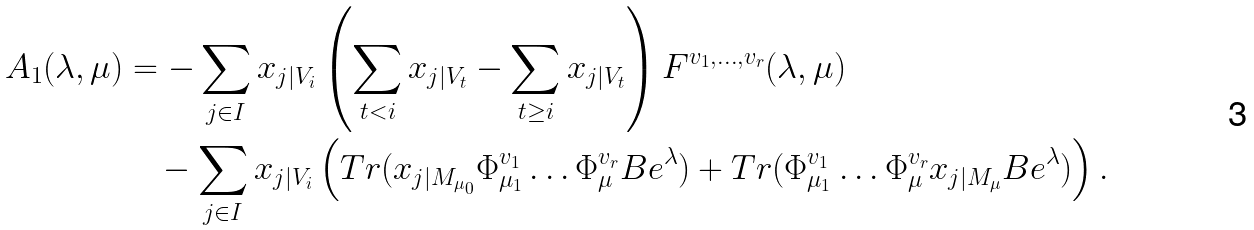Convert formula to latex. <formula><loc_0><loc_0><loc_500><loc_500>A _ { 1 } ( \lambda , \mu ) & = - \sum _ { j \in I } x _ { j | V _ { i } } \left ( \sum _ { t < i } x _ { j | V _ { t } } - \sum _ { t \geq i } x _ { j | V _ { t } } \right ) F ^ { v _ { 1 } , \dots , v _ { r } } ( \lambda , \mu ) \\ & \quad - \sum _ { j \in I } x _ { j | V _ { i } } \left ( T r ( x _ { j | M _ { \mu _ { 0 } } } \Phi ^ { v _ { 1 } } _ { \mu _ { 1 } } \dots \Phi ^ { v _ { r } } _ { \mu } B e ^ { \lambda } ) + T r ( \Phi ^ { v _ { 1 } } _ { \mu _ { 1 } } \dots \Phi ^ { v _ { r } } _ { \mu } x _ { j | M _ { \mu } } B e ^ { \lambda } ) \right ) .</formula> 